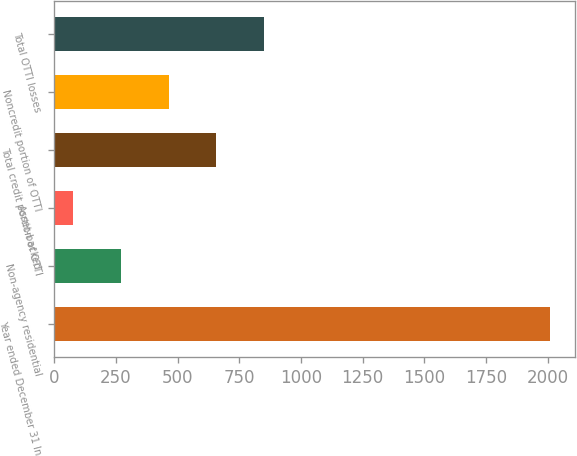<chart> <loc_0><loc_0><loc_500><loc_500><bar_chart><fcel>Year ended December 31 In<fcel>Non-agency residential<fcel>Asset-backed<fcel>Total credit portion of OTTI<fcel>Noncredit portion of OTTI<fcel>Total OTTI losses<nl><fcel>2010<fcel>271.2<fcel>78<fcel>657.6<fcel>464.4<fcel>850.8<nl></chart> 